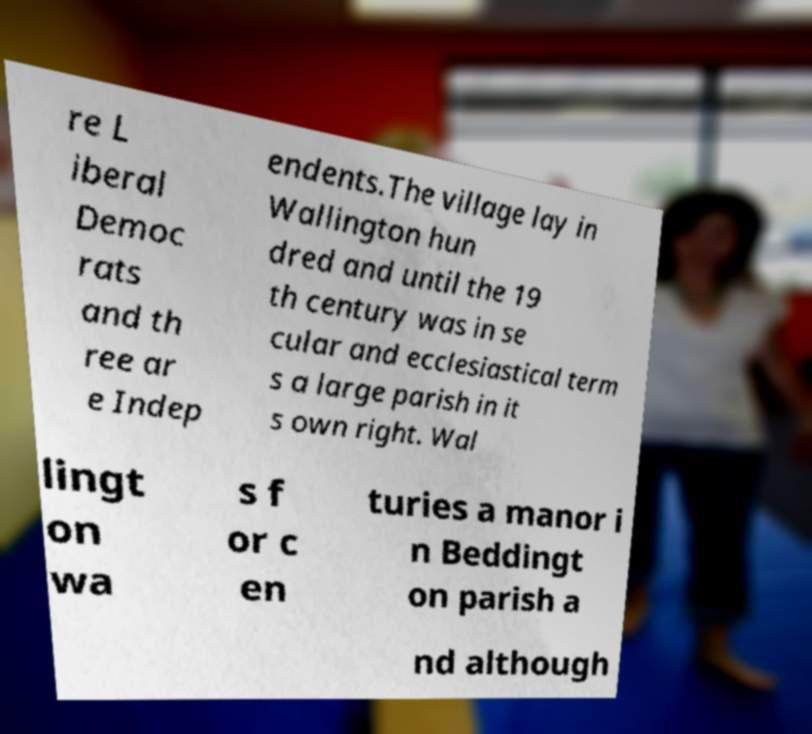Can you accurately transcribe the text from the provided image for me? re L iberal Democ rats and th ree ar e Indep endents.The village lay in Wallington hun dred and until the 19 th century was in se cular and ecclesiastical term s a large parish in it s own right. Wal lingt on wa s f or c en turies a manor i n Beddingt on parish a nd although 